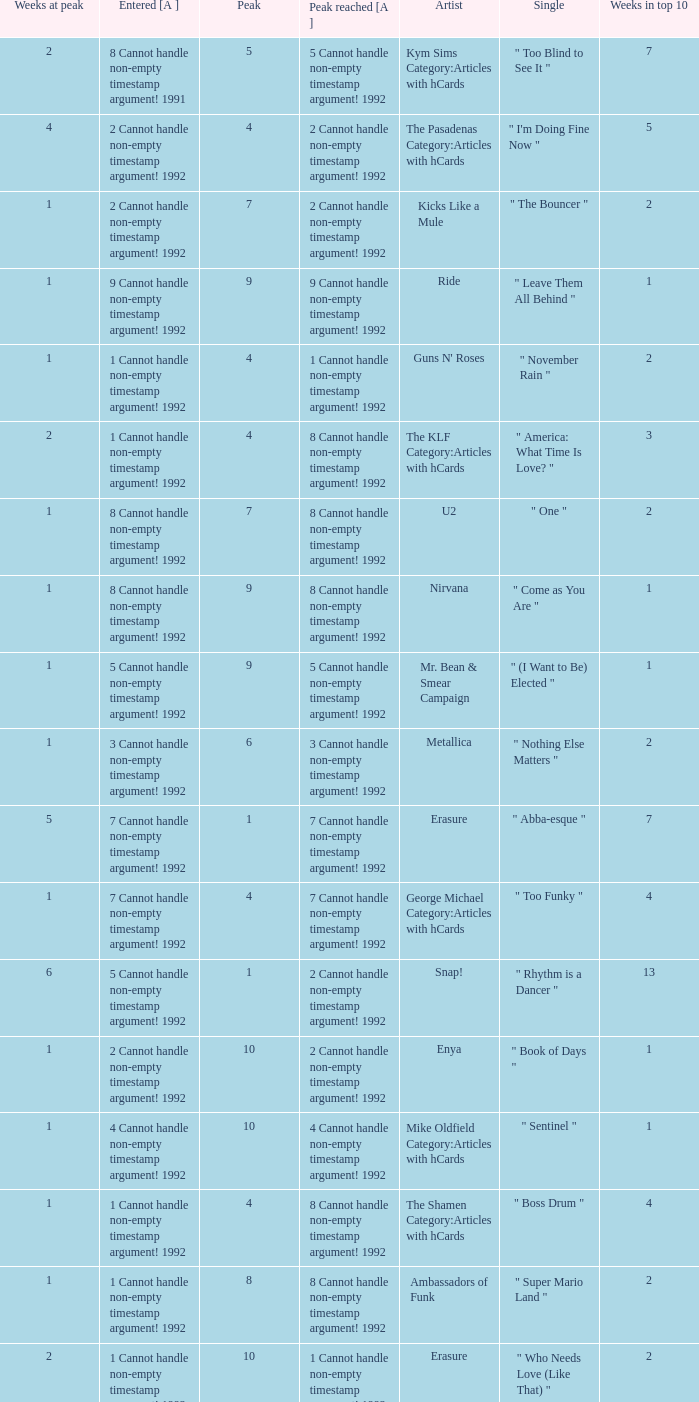If the peak reached is 6 cannot handle non-empty timestamp argument! 1992, what is the entered? 6 Cannot handle non-empty timestamp argument! 1992. 